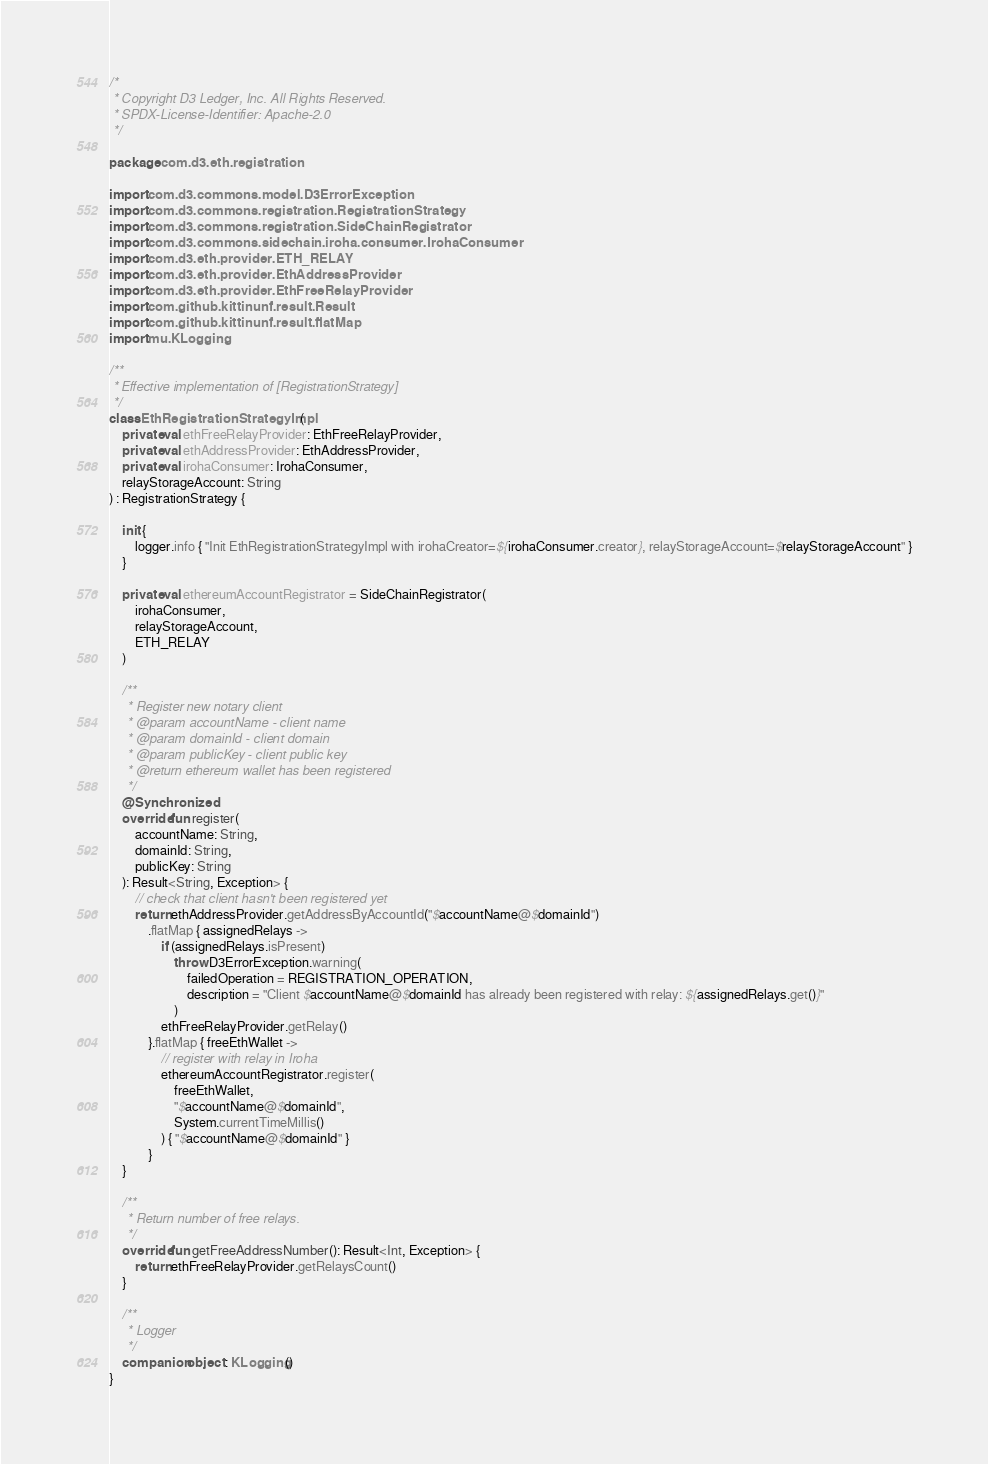<code> <loc_0><loc_0><loc_500><loc_500><_Kotlin_>/*
 * Copyright D3 Ledger, Inc. All Rights Reserved.
 * SPDX-License-Identifier: Apache-2.0
 */

package com.d3.eth.registration

import com.d3.commons.model.D3ErrorException
import com.d3.commons.registration.RegistrationStrategy
import com.d3.commons.registration.SideChainRegistrator
import com.d3.commons.sidechain.iroha.consumer.IrohaConsumer
import com.d3.eth.provider.ETH_RELAY
import com.d3.eth.provider.EthAddressProvider
import com.d3.eth.provider.EthFreeRelayProvider
import com.github.kittinunf.result.Result
import com.github.kittinunf.result.flatMap
import mu.KLogging

/**
 * Effective implementation of [RegistrationStrategy]
 */
class EthRegistrationStrategyImpl(
    private val ethFreeRelayProvider: EthFreeRelayProvider,
    private val ethAddressProvider: EthAddressProvider,
    private val irohaConsumer: IrohaConsumer,
    relayStorageAccount: String
) : RegistrationStrategy {

    init {
        logger.info { "Init EthRegistrationStrategyImpl with irohaCreator=${irohaConsumer.creator}, relayStorageAccount=$relayStorageAccount" }
    }

    private val ethereumAccountRegistrator = SideChainRegistrator(
        irohaConsumer,
        relayStorageAccount,
        ETH_RELAY
    )

    /**
     * Register new notary client
     * @param accountName - client name
     * @param domainId - client domain
     * @param publicKey - client public key
     * @return ethereum wallet has been registered
     */
    @Synchronized
    override fun register(
        accountName: String,
        domainId: String,
        publicKey: String
    ): Result<String, Exception> {
        // check that client hasn't been registered yet
        return ethAddressProvider.getAddressByAccountId("$accountName@$domainId")
            .flatMap { assignedRelays ->
                if (assignedRelays.isPresent)
                    throw D3ErrorException.warning(
                        failedOperation = REGISTRATION_OPERATION,
                        description = "Client $accountName@$domainId has already been registered with relay: ${assignedRelays.get()}"
                    )
                ethFreeRelayProvider.getRelay()
            }.flatMap { freeEthWallet ->
                // register with relay in Iroha
                ethereumAccountRegistrator.register(
                    freeEthWallet,
                    "$accountName@$domainId",
                    System.currentTimeMillis()
                ) { "$accountName@$domainId" }
            }
    }

    /**
     * Return number of free relays.
     */
    override fun getFreeAddressNumber(): Result<Int, Exception> {
        return ethFreeRelayProvider.getRelaysCount()
    }

    /**
     * Logger
     */
    companion object : KLogging()
}
</code> 